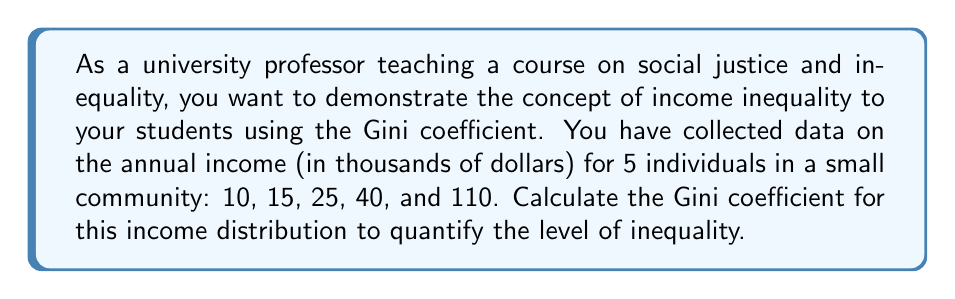Can you solve this math problem? To calculate the Gini coefficient, we'll follow these steps:

1. Order the incomes from lowest to highest:
   10, 15, 25, 40, 110

2. Calculate the cumulative share of the population (x) and the cumulative share of income (y):

   $$\begin{array}{|c|c|c|c|c|}
   \hline
   \text{Income} & \text{Cum. Pop.} & \text{Cum. Income} & x & y \\
   \hline
   10 & 1 & 10 & 0.2 & 0.05 \\
   15 & 2 & 25 & 0.4 & 0.125 \\
   25 & 3 & 50 & 0.6 & 0.25 \\
   40 & 4 & 90 & 0.8 & 0.45 \\
   110 & 5 & 200 & 1.0 & 1.0 \\
   \hline
   \end{array}$$

3. Calculate the area under the Lorenz curve (B) using the trapezoidal rule:

   $$B = \frac{1}{2} \sum_{i=1}^{n-1} (x_{i+1} - x_i)(y_i + y_{i+1})$$

   $$B = \frac{1}{2}[(0.4-0.2)(0.05+0.125) + (0.6-0.4)(0.125+0.25) + (0.8-0.6)(0.25+0.45) + (1.0-0.8)(0.45+1.0)]$$
   $$B = \frac{1}{2}[0.2(0.175) + 0.2(0.375) + 0.2(0.7) + 0.2(1.45)]$$
   $$B = \frac{1}{2}[0.035 + 0.075 + 0.14 + 0.29]$$
   $$B = \frac{1}{2}(0.54) = 0.27$$

4. Calculate the area of perfect equality (A):
   $$A = \frac{1}{2}$$

5. Calculate the Gini coefficient:
   $$\text{Gini} = \frac{A - B}{A} = \frac{0.5 - 0.27}{0.5} = \frac{0.23}{0.5} = 0.46$$
Answer: The Gini coefficient for the given income distribution is 0.46. 